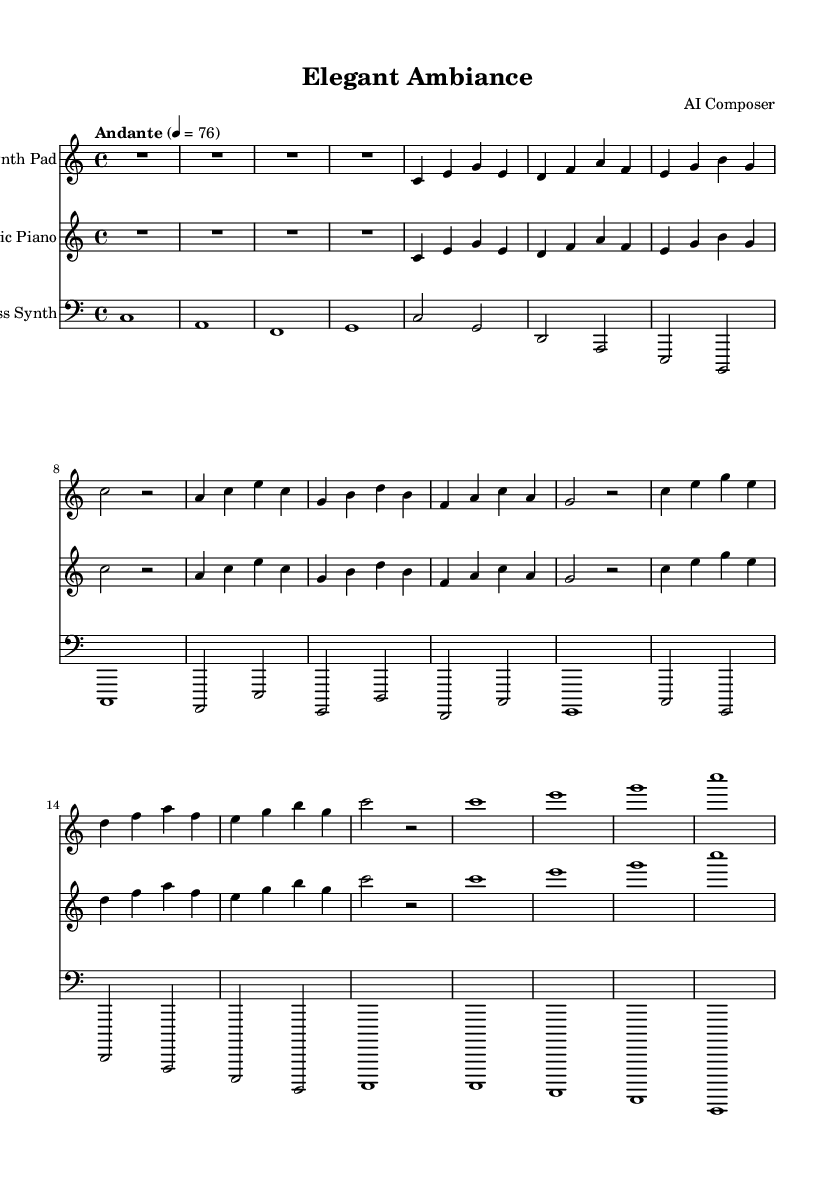What is the key signature of this music? The key signature is indicated at the beginning of the staff and shows that this piece is composed in C major, which has no sharps or flats.
Answer: C major What is the time signature of this piece? The time signature appears at the beginning of the score, showing a 4/4 meter, which means there are four beats in each measure and the quarter note receives one beat.
Answer: 4/4 What is the tempo marking for this composition? The tempo marking "Andante" can be found at the top of the score, which suggests a moderate pace, specifically a speed of 76 beats per minute as indicated by the numbers following the term.
Answer: Andante 4 = 76 What instruments are featured in this arrangement? The instruments can be identified by their respective staff labels: the Synth Pad, Electric Piano, and Bass Synth. This information can be found next to each staff on the score.
Answer: Synth Pad, Electric Piano, Bass Synth How many measures are there in the Synth Pad part? By counting the measures in the Synth Pad staff, we find that there are 8 measures present throughout the music.
Answer: 8 Which instrument plays the first note of the piece? The first note appears in the Synth Pad staff as a rest (R1*4), indicating a pause, with the music beginning in the second measure. Thus, the first audible note is played by the Synth Pad when it resumes after the rest.
Answer: Synth Pad 